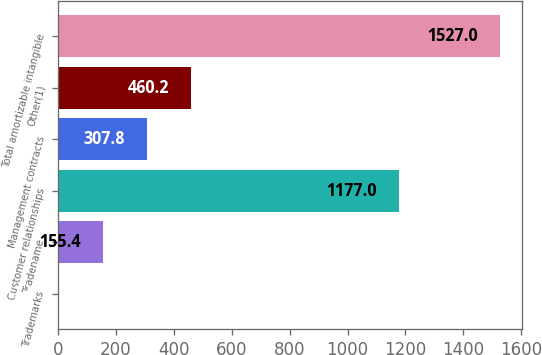<chart> <loc_0><loc_0><loc_500><loc_500><bar_chart><fcel>Trademarks<fcel>Tradename<fcel>Customer relationships<fcel>Management contracts<fcel>Other(1)<fcel>Total amortizable intangible<nl><fcel>3<fcel>155.4<fcel>1177<fcel>307.8<fcel>460.2<fcel>1527<nl></chart> 